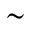<formula> <loc_0><loc_0><loc_500><loc_500>\sim</formula> 